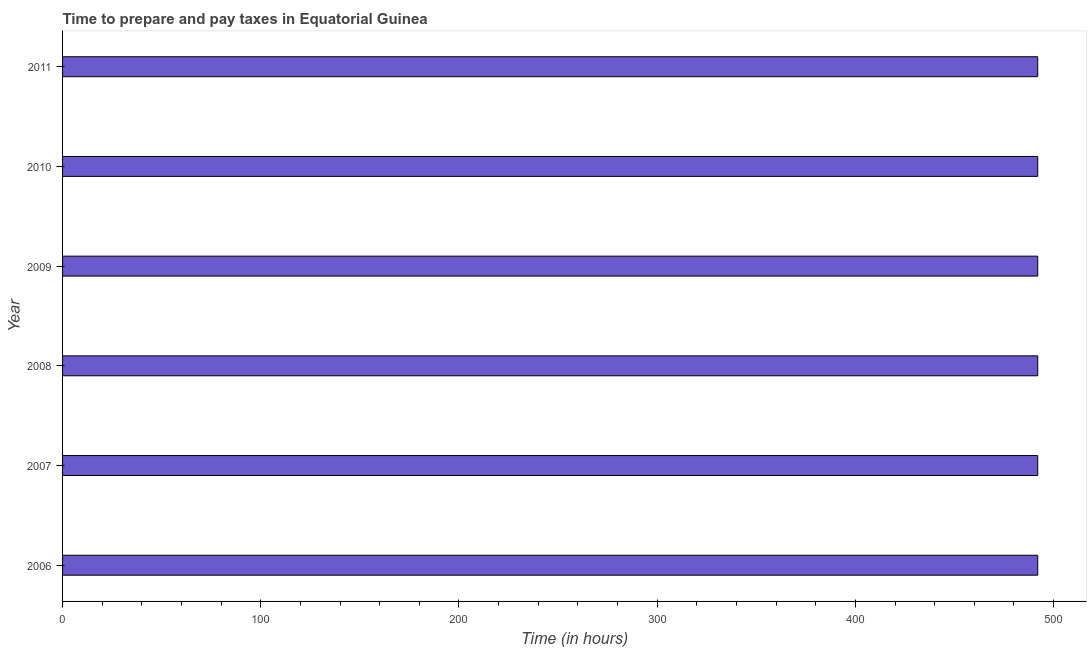Does the graph contain any zero values?
Make the answer very short. No. What is the title of the graph?
Give a very brief answer. Time to prepare and pay taxes in Equatorial Guinea. What is the label or title of the X-axis?
Provide a short and direct response. Time (in hours). What is the label or title of the Y-axis?
Provide a short and direct response. Year. What is the time to prepare and pay taxes in 2010?
Provide a succinct answer. 492. Across all years, what is the maximum time to prepare and pay taxes?
Keep it short and to the point. 492. Across all years, what is the minimum time to prepare and pay taxes?
Your answer should be very brief. 492. In which year was the time to prepare and pay taxes maximum?
Ensure brevity in your answer.  2006. What is the sum of the time to prepare and pay taxes?
Your answer should be compact. 2952. What is the average time to prepare and pay taxes per year?
Offer a very short reply. 492. What is the median time to prepare and pay taxes?
Ensure brevity in your answer.  492. In how many years, is the time to prepare and pay taxes greater than 180 hours?
Your response must be concise. 6. Do a majority of the years between 2009 and 2010 (inclusive) have time to prepare and pay taxes greater than 120 hours?
Ensure brevity in your answer.  Yes. Is the sum of the time to prepare and pay taxes in 2008 and 2009 greater than the maximum time to prepare and pay taxes across all years?
Offer a very short reply. Yes. What is the difference between the highest and the lowest time to prepare and pay taxes?
Ensure brevity in your answer.  0. In how many years, is the time to prepare and pay taxes greater than the average time to prepare and pay taxes taken over all years?
Offer a very short reply. 0. What is the Time (in hours) of 2006?
Offer a very short reply. 492. What is the Time (in hours) of 2007?
Keep it short and to the point. 492. What is the Time (in hours) of 2008?
Provide a short and direct response. 492. What is the Time (in hours) of 2009?
Ensure brevity in your answer.  492. What is the Time (in hours) of 2010?
Your answer should be compact. 492. What is the Time (in hours) in 2011?
Your answer should be very brief. 492. What is the difference between the Time (in hours) in 2006 and 2009?
Keep it short and to the point. 0. What is the difference between the Time (in hours) in 2006 and 2010?
Your response must be concise. 0. What is the difference between the Time (in hours) in 2007 and 2008?
Your answer should be very brief. 0. What is the difference between the Time (in hours) in 2008 and 2009?
Your answer should be compact. 0. What is the difference between the Time (in hours) in 2008 and 2010?
Your answer should be very brief. 0. What is the difference between the Time (in hours) in 2009 and 2010?
Your answer should be compact. 0. What is the ratio of the Time (in hours) in 2007 to that in 2009?
Your answer should be compact. 1. What is the ratio of the Time (in hours) in 2007 to that in 2011?
Provide a short and direct response. 1. What is the ratio of the Time (in hours) in 2008 to that in 2010?
Ensure brevity in your answer.  1. What is the ratio of the Time (in hours) in 2009 to that in 2010?
Offer a terse response. 1. What is the ratio of the Time (in hours) in 2010 to that in 2011?
Your answer should be very brief. 1. 